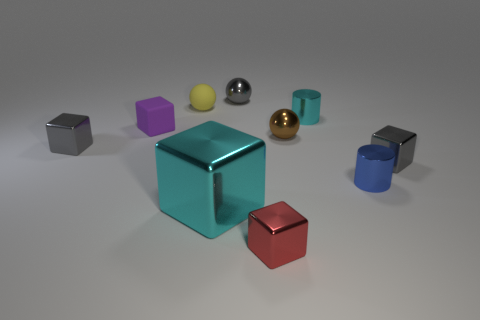Are there more tiny yellow matte balls behind the gray metal ball than cyan metal things?
Provide a succinct answer. No. There is a small gray block that is in front of the gray thing that is to the left of the tiny metallic thing behind the small cyan metal cylinder; what is it made of?
Keep it short and to the point. Metal. Is the material of the brown thing the same as the cylinder that is behind the brown ball?
Your answer should be very brief. Yes. What is the material of the gray object that is the same shape as the tiny yellow rubber object?
Keep it short and to the point. Metal. Are there any other things that are the same material as the large object?
Provide a short and direct response. Yes. Is the number of small metallic balls that are behind the brown thing greater than the number of small balls that are behind the large cyan cube?
Provide a short and direct response. No. The big object that is made of the same material as the tiny red object is what shape?
Provide a short and direct response. Cube. What number of other things are there of the same shape as the red object?
Keep it short and to the point. 4. There is a gray shiny thing that is to the left of the cyan shiny block; what shape is it?
Give a very brief answer. Cube. The small rubber sphere is what color?
Give a very brief answer. Yellow. 